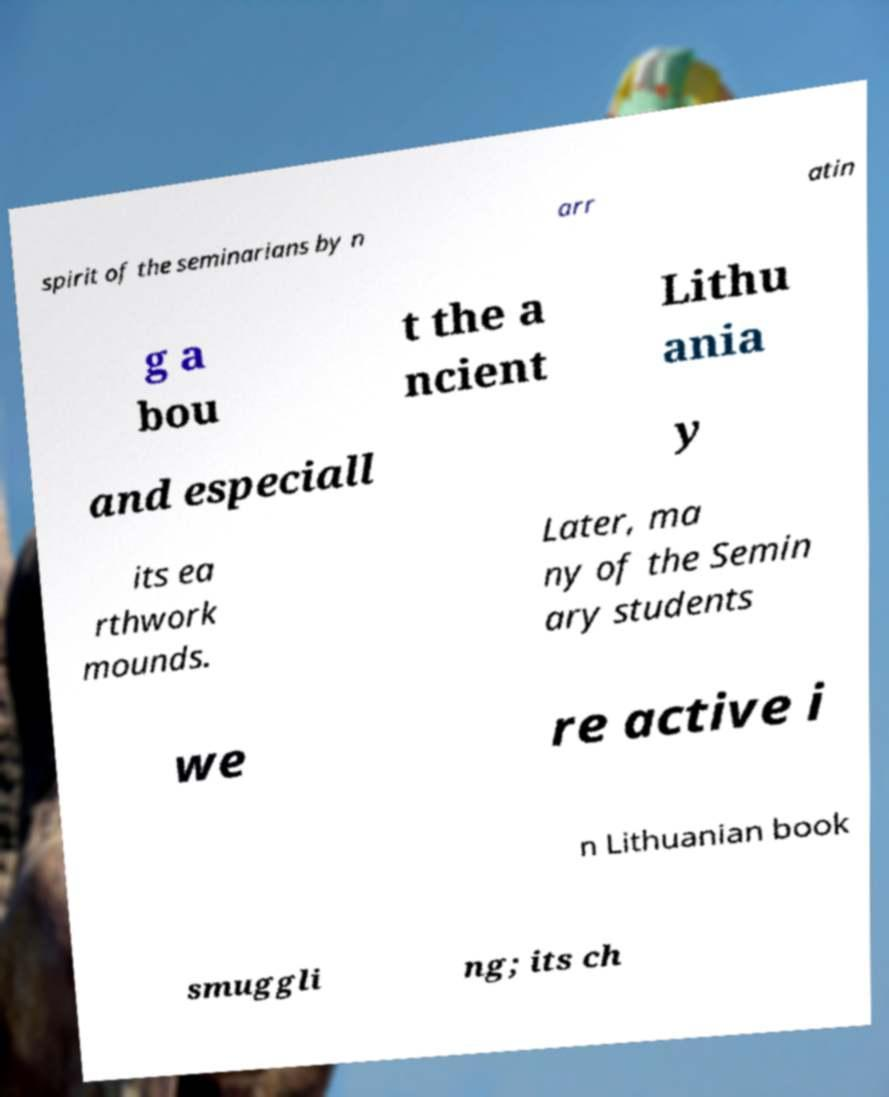What messages or text are displayed in this image? I need them in a readable, typed format. spirit of the seminarians by n arr atin g a bou t the a ncient Lithu ania and especiall y its ea rthwork mounds. Later, ma ny of the Semin ary students we re active i n Lithuanian book smuggli ng; its ch 